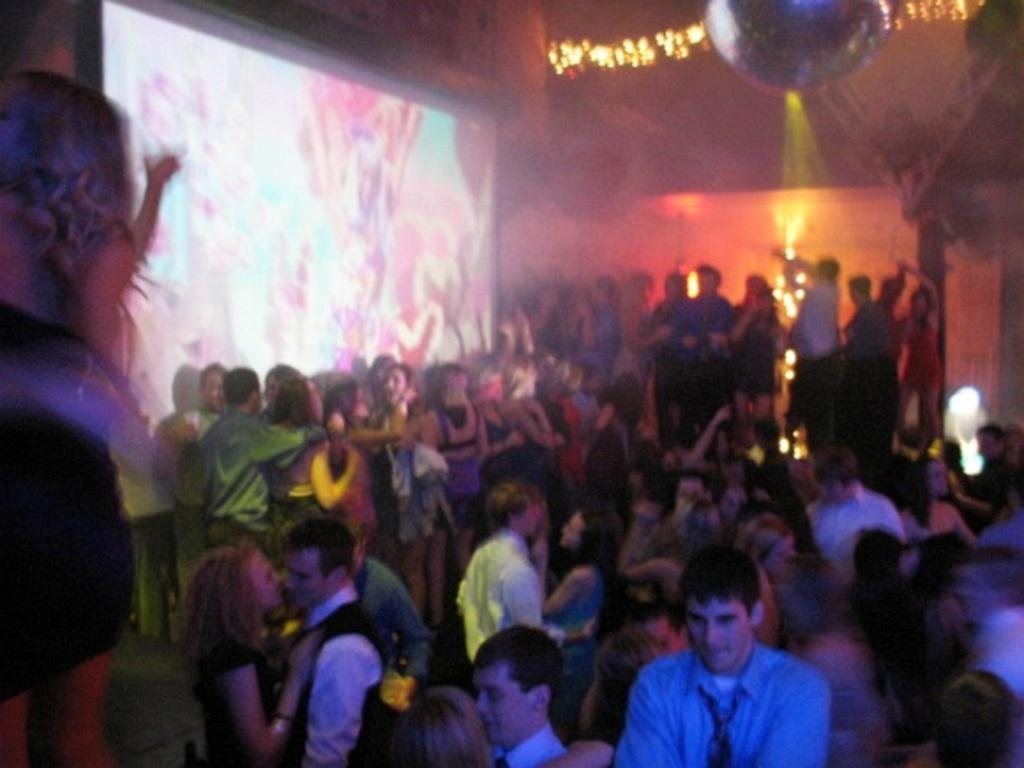How many people are in the group in the image? There is a group of people in the image, but the exact number is not specified. What can be seen on the left side of the group? There is a screen to the left of the group. What is the background of the image like? There are many lights and a wall in the background. How can you describe the attire of the people in the group? The people are wearing different color dresses. What historical event is being commemorated by the group in the image? There is no indication of a historical event being commemorated in the image. How many things can be seen on the wall in the background? The provided facts do not specify the number of things on the wall in the background. 